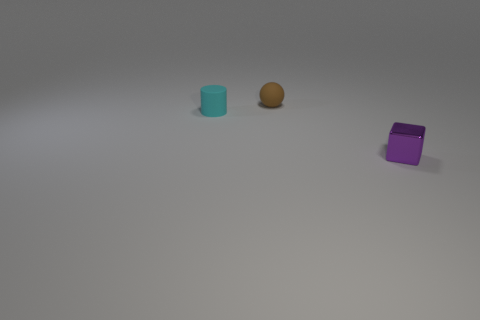Add 1 tiny balls. How many objects exist? 4 Subtract all cubes. How many objects are left? 2 Subtract 1 balls. How many balls are left? 0 Subtract 0 yellow cylinders. How many objects are left? 3 Subtract all green blocks. Subtract all yellow cylinders. How many blocks are left? 1 Subtract all cyan spheres. How many red cylinders are left? 0 Subtract all small purple shiny things. Subtract all cyan cylinders. How many objects are left? 1 Add 3 tiny cylinders. How many tiny cylinders are left? 4 Add 1 cyan things. How many cyan things exist? 2 